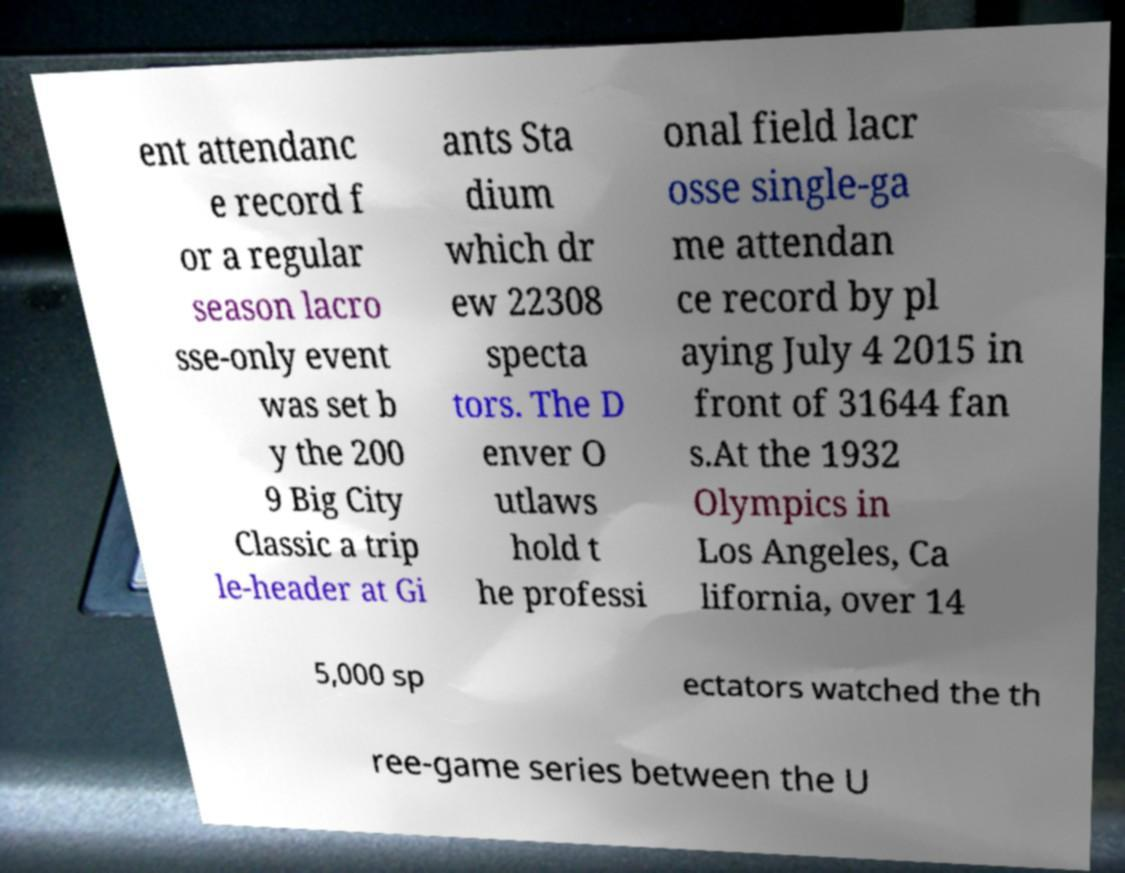There's text embedded in this image that I need extracted. Can you transcribe it verbatim? ent attendanc e record f or a regular season lacro sse-only event was set b y the 200 9 Big City Classic a trip le-header at Gi ants Sta dium which dr ew 22308 specta tors. The D enver O utlaws hold t he professi onal field lacr osse single-ga me attendan ce record by pl aying July 4 2015 in front of 31644 fan s.At the 1932 Olympics in Los Angeles, Ca lifornia, over 14 5,000 sp ectators watched the th ree-game series between the U 